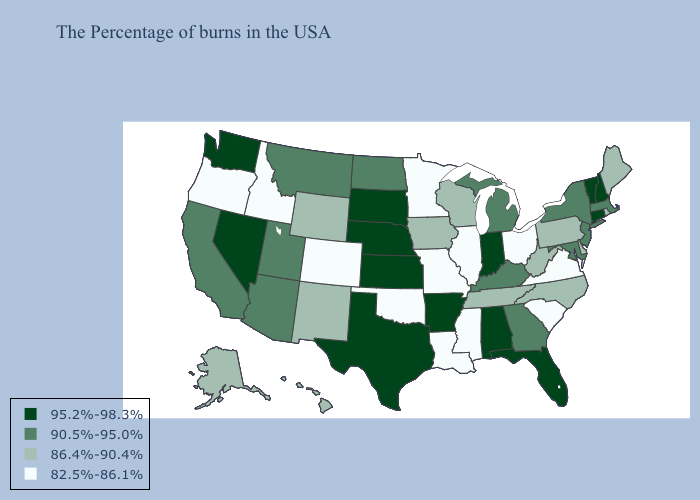Which states have the lowest value in the USA?
Keep it brief. Virginia, South Carolina, Ohio, Illinois, Mississippi, Louisiana, Missouri, Minnesota, Oklahoma, Colorado, Idaho, Oregon. What is the lowest value in states that border Minnesota?
Quick response, please. 86.4%-90.4%. What is the lowest value in the Northeast?
Be succinct. 86.4%-90.4%. What is the lowest value in the West?
Give a very brief answer. 82.5%-86.1%. Does Rhode Island have the highest value in the Northeast?
Short answer required. No. Name the states that have a value in the range 86.4%-90.4%?
Answer briefly. Maine, Rhode Island, Delaware, Pennsylvania, North Carolina, West Virginia, Tennessee, Wisconsin, Iowa, Wyoming, New Mexico, Alaska, Hawaii. Is the legend a continuous bar?
Answer briefly. No. Which states hav the highest value in the MidWest?
Be succinct. Indiana, Kansas, Nebraska, South Dakota. Among the states that border New Hampshire , which have the highest value?
Answer briefly. Vermont. Name the states that have a value in the range 95.2%-98.3%?
Quick response, please. New Hampshire, Vermont, Connecticut, Florida, Indiana, Alabama, Arkansas, Kansas, Nebraska, Texas, South Dakota, Nevada, Washington. What is the value of South Carolina?
Quick response, please. 82.5%-86.1%. Name the states that have a value in the range 86.4%-90.4%?
Keep it brief. Maine, Rhode Island, Delaware, Pennsylvania, North Carolina, West Virginia, Tennessee, Wisconsin, Iowa, Wyoming, New Mexico, Alaska, Hawaii. What is the value of Vermont?
Keep it brief. 95.2%-98.3%. Name the states that have a value in the range 95.2%-98.3%?
Be succinct. New Hampshire, Vermont, Connecticut, Florida, Indiana, Alabama, Arkansas, Kansas, Nebraska, Texas, South Dakota, Nevada, Washington. Among the states that border Wisconsin , does Michigan have the highest value?
Give a very brief answer. Yes. 